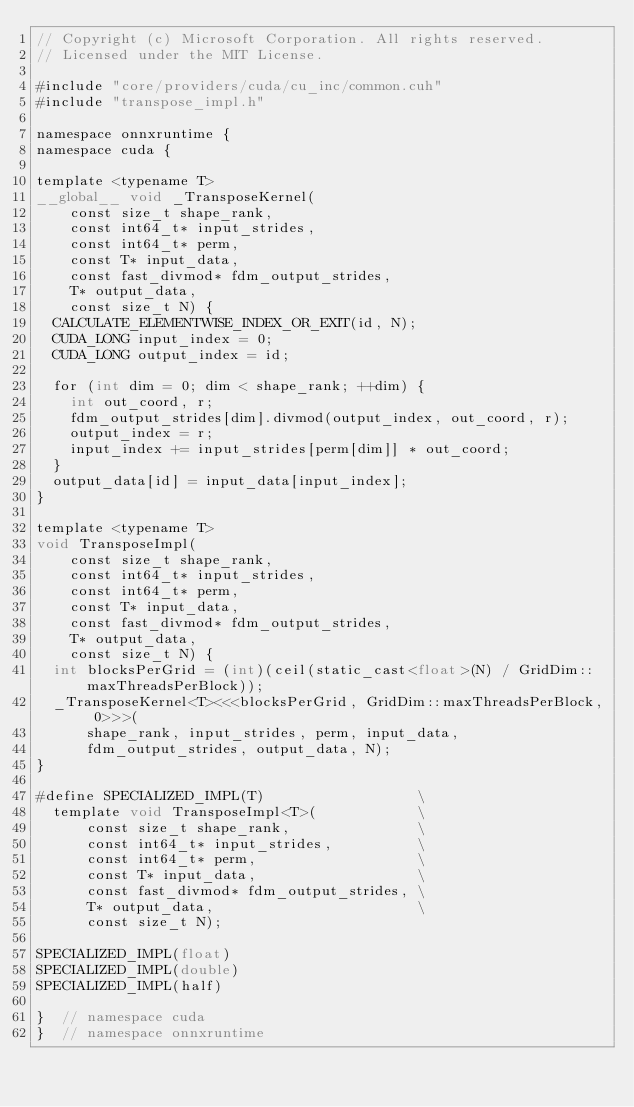Convert code to text. <code><loc_0><loc_0><loc_500><loc_500><_Cuda_>// Copyright (c) Microsoft Corporation. All rights reserved.
// Licensed under the MIT License.

#include "core/providers/cuda/cu_inc/common.cuh"
#include "transpose_impl.h"

namespace onnxruntime {
namespace cuda {

template <typename T>
__global__ void _TransposeKernel(
    const size_t shape_rank,
    const int64_t* input_strides,
    const int64_t* perm,
    const T* input_data,
    const fast_divmod* fdm_output_strides,
    T* output_data,
    const size_t N) {
  CALCULATE_ELEMENTWISE_INDEX_OR_EXIT(id, N);
  CUDA_LONG input_index = 0;
  CUDA_LONG output_index = id;

  for (int dim = 0; dim < shape_rank; ++dim) {
    int out_coord, r;
    fdm_output_strides[dim].divmod(output_index, out_coord, r);
    output_index = r;
    input_index += input_strides[perm[dim]] * out_coord;
  }
  output_data[id] = input_data[input_index];
}

template <typename T>
void TransposeImpl(
    const size_t shape_rank,
    const int64_t* input_strides,
    const int64_t* perm,
    const T* input_data,
    const fast_divmod* fdm_output_strides,
    T* output_data,
    const size_t N) {
  int blocksPerGrid = (int)(ceil(static_cast<float>(N) / GridDim::maxThreadsPerBlock));
  _TransposeKernel<T><<<blocksPerGrid, GridDim::maxThreadsPerBlock, 0>>>(
      shape_rank, input_strides, perm, input_data,
      fdm_output_strides, output_data, N);
}

#define SPECIALIZED_IMPL(T)                  \
  template void TransposeImpl<T>(            \
      const size_t shape_rank,               \
      const int64_t* input_strides,          \
      const int64_t* perm,                   \
      const T* input_data,                   \
      const fast_divmod* fdm_output_strides, \
      T* output_data,                        \
      const size_t N);

SPECIALIZED_IMPL(float)
SPECIALIZED_IMPL(double)
SPECIALIZED_IMPL(half)

}  // namespace cuda
}  // namespace onnxruntime
</code> 